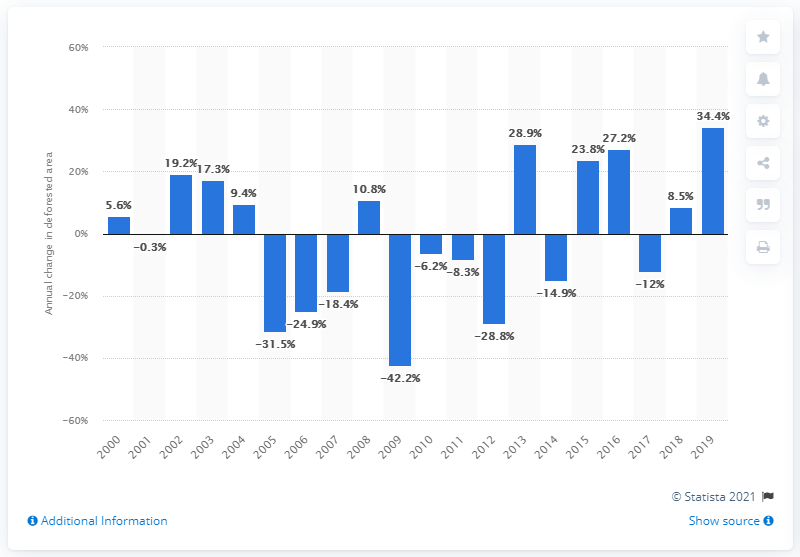Give some essential details in this illustration. In 2017, the rate of deforestation in the Brazilian Amazon was 12 percent lower than in the previous year. 